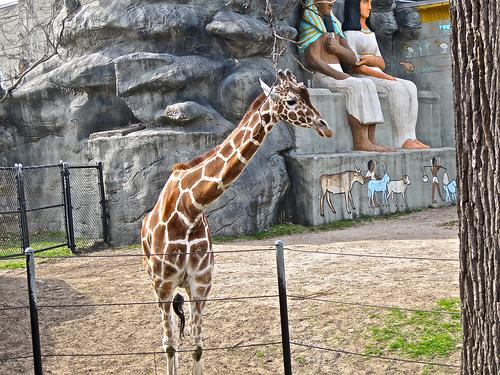Question: what is on the right?
Choices:
A. A horse.
B. Tree trunk.
C. A pole.
D. A stop sign.
Answer with the letter. Answer: B Question: how is the fence made?
Choices:
A. Wood.
B. Wire and posts.
C. Steel.
D. Chain link.
Answer with the letter. Answer: B Question: why is the fence there?
Choices:
A. To protect visitors.
B. Keep out trespassers.
C. Decoration.
D. Hold giraffe.
Answer with the letter. Answer: D Question: what is in the foreground?
Choices:
A. Beach.
B. Trees.
C. A house.
D. Fence.
Answer with the letter. Answer: D Question: where are the rocks?
Choices:
A. On the beach.
B. In the water.
C. On side of the fence.
D. Background.
Answer with the letter. Answer: D 